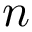Convert formula to latex. <formula><loc_0><loc_0><loc_500><loc_500>n</formula> 